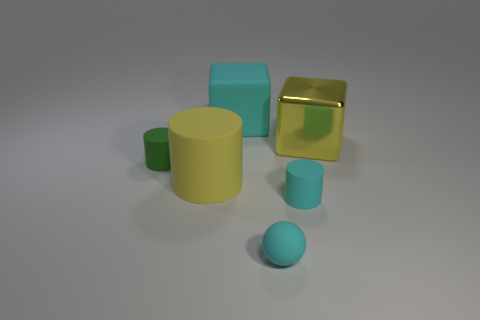Add 1 large yellow metal things. How many objects exist? 7 Subtract all blocks. How many objects are left? 4 Subtract all large yellow blocks. Subtract all large metallic cubes. How many objects are left? 4 Add 3 yellow cubes. How many yellow cubes are left? 4 Add 3 tiny yellow shiny cubes. How many tiny yellow shiny cubes exist? 3 Subtract 0 brown cylinders. How many objects are left? 6 